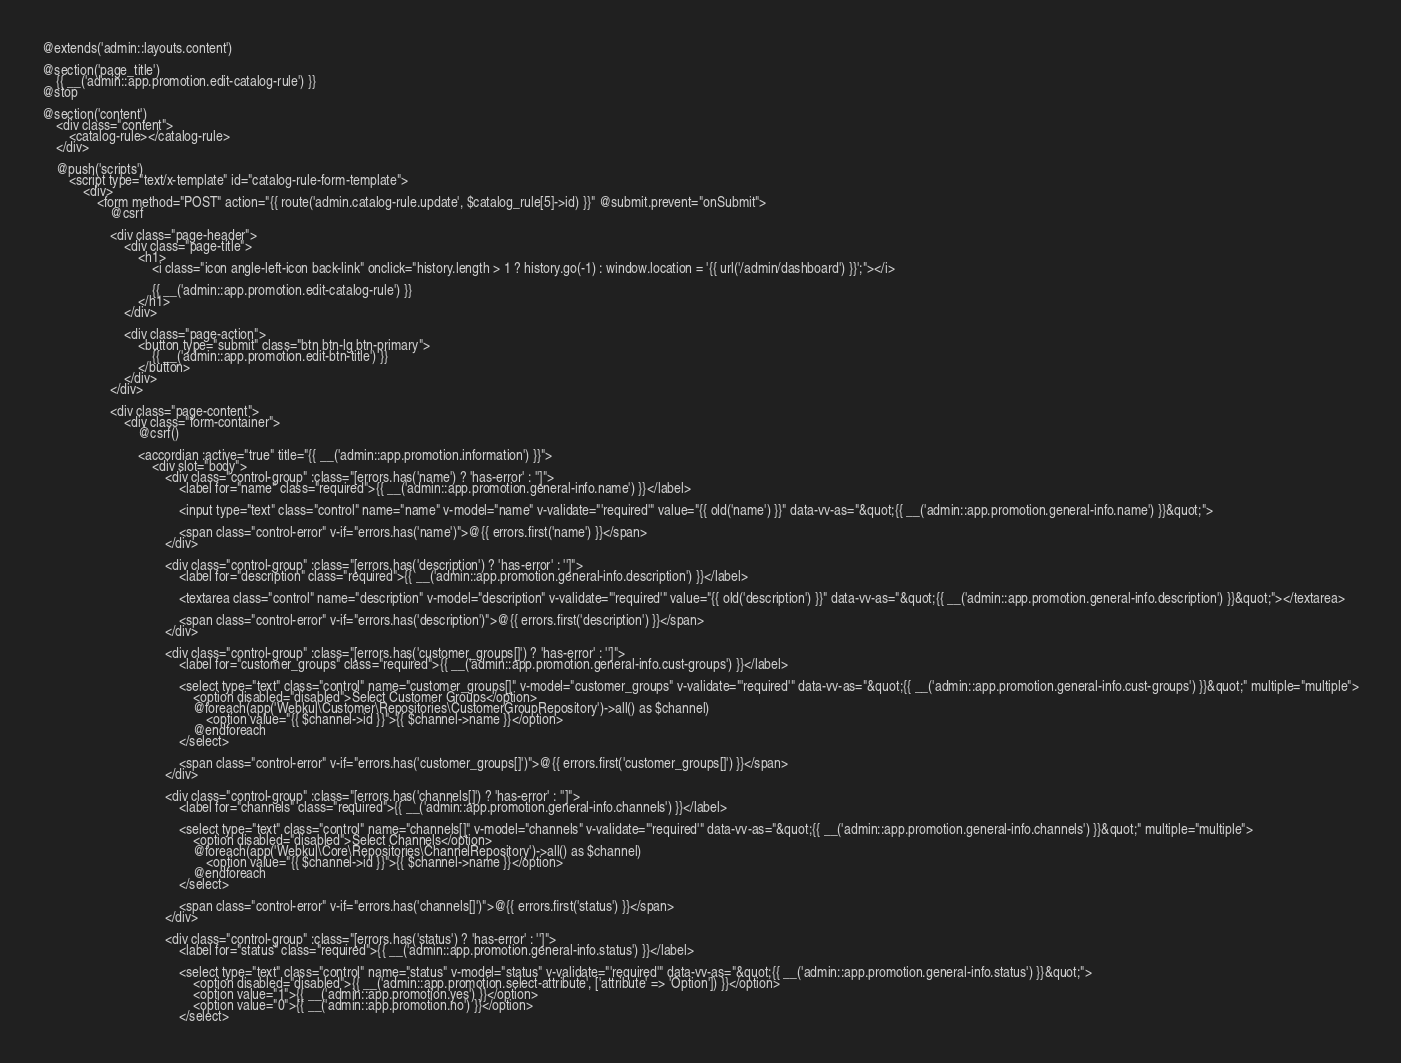Convert code to text. <code><loc_0><loc_0><loc_500><loc_500><_PHP_>@extends('admin::layouts.content')

@section('page_title')
    {{ __('admin::app.promotion.edit-catalog-rule') }}
@stop

@section('content')
    <div class="content">
        <catalog-rule></catalog-rule>
    </div>

    @push('scripts')
        <script type="text/x-template" id="catalog-rule-form-template">
            <div>
                <form method="POST" action="{{ route('admin.catalog-rule.update', $catalog_rule[5]->id) }}" @submit.prevent="onSubmit">
                    @csrf

                    <div class="page-header">
                        <div class="page-title">
                            <h1>
                                <i class="icon angle-left-icon back-link" onclick="history.length > 1 ? history.go(-1) : window.location = '{{ url('/admin/dashboard') }}';"></i>

                                {{ __('admin::app.promotion.edit-catalog-rule') }}
                            </h1>
                        </div>

                        <div class="page-action">
                            <button type="submit" class="btn btn-lg btn-primary">
                                {{ __('admin::app.promotion.edit-btn-title') }}
                            </button>
                        </div>
                    </div>

                    <div class="page-content">
                        <div class="form-container">
                            @csrf()

                            <accordian :active="true" title="{{ __('admin::app.promotion.information') }}">
                                <div slot="body">
                                    <div class="control-group" :class="[errors.has('name') ? 'has-error' : '']">
                                        <label for="name" class="required">{{ __('admin::app.promotion.general-info.name') }}</label>

                                        <input type="text" class="control" name="name" v-model="name" v-validate="'required'" value="{{ old('name') }}" data-vv-as="&quot;{{ __('admin::app.promotion.general-info.name') }}&quot;">

                                        <span class="control-error" v-if="errors.has('name')">@{{ errors.first('name') }}</span>
                                    </div>

                                    <div class="control-group" :class="[errors.has('description') ? 'has-error' : '']">
                                        <label for="description" class="required">{{ __('admin::app.promotion.general-info.description') }}</label>

                                        <textarea class="control" name="description" v-model="description" v-validate="'required'" value="{{ old('description') }}" data-vv-as="&quot;{{ __('admin::app.promotion.general-info.description') }}&quot;"></textarea>

                                        <span class="control-error" v-if="errors.has('description')">@{{ errors.first('description') }}</span>
                                    </div>

                                    <div class="control-group" :class="[errors.has('customer_groups[]') ? 'has-error' : '']">
                                        <label for="customer_groups" class="required">{{ __('admin::app.promotion.general-info.cust-groups') }}</label>

                                        <select type="text" class="control" name="customer_groups[]" v-model="customer_groups" v-validate="'required'" data-vv-as="&quot;{{ __('admin::app.promotion.general-info.cust-groups') }}&quot;" multiple="multiple">
                                            <option disabled="disabled">Select Customer Groups</option>
                                            @foreach(app('Webkul\Customer\Repositories\CustomerGroupRepository')->all() as $channel)
                                                <option value="{{ $channel->id }}">{{ $channel->name }}</option>
                                            @endforeach
                                        </select>

                                        <span class="control-error" v-if="errors.has('customer_groups[]')">@{{ errors.first('customer_groups[]') }}</span>
                                    </div>

                                    <div class="control-group" :class="[errors.has('channels[]') ? 'has-error' : '']">
                                        <label for="channels" class="required">{{ __('admin::app.promotion.general-info.channels') }}</label>

                                        <select type="text" class="control" name="channels[]" v-model="channels" v-validate="'required'" data-vv-as="&quot;{{ __('admin::app.promotion.general-info.channels') }}&quot;" multiple="multiple">
                                            <option disabled="disabled">Select Channels</option>
                                            @foreach(app('Webkul\Core\Repositories\ChannelRepository')->all() as $channel)
                                                <option value="{{ $channel->id }}">{{ $channel->name }}</option>
                                            @endforeach
                                        </select>

                                        <span class="control-error" v-if="errors.has('channels[]')">@{{ errors.first('status') }}</span>
                                    </div>

                                    <div class="control-group" :class="[errors.has('status') ? 'has-error' : '']">
                                        <label for="status" class="required">{{ __('admin::app.promotion.general-info.status') }}</label>

                                        <select type="text" class="control" name="status" v-model="status" v-validate="'required'" data-vv-as="&quot;{{ __('admin::app.promotion.general-info.status') }}&quot;">
                                            <option disabled="disabled">{{ __('admin::app.promotion.select-attribute', ['attribute' => 'Option']) }}</option>
                                            <option value="1">{{ __('admin::app.promotion.yes') }}</option>
                                            <option value="0">{{ __('admin::app.promotion.no') }}</option>
                                        </select>
</code> 